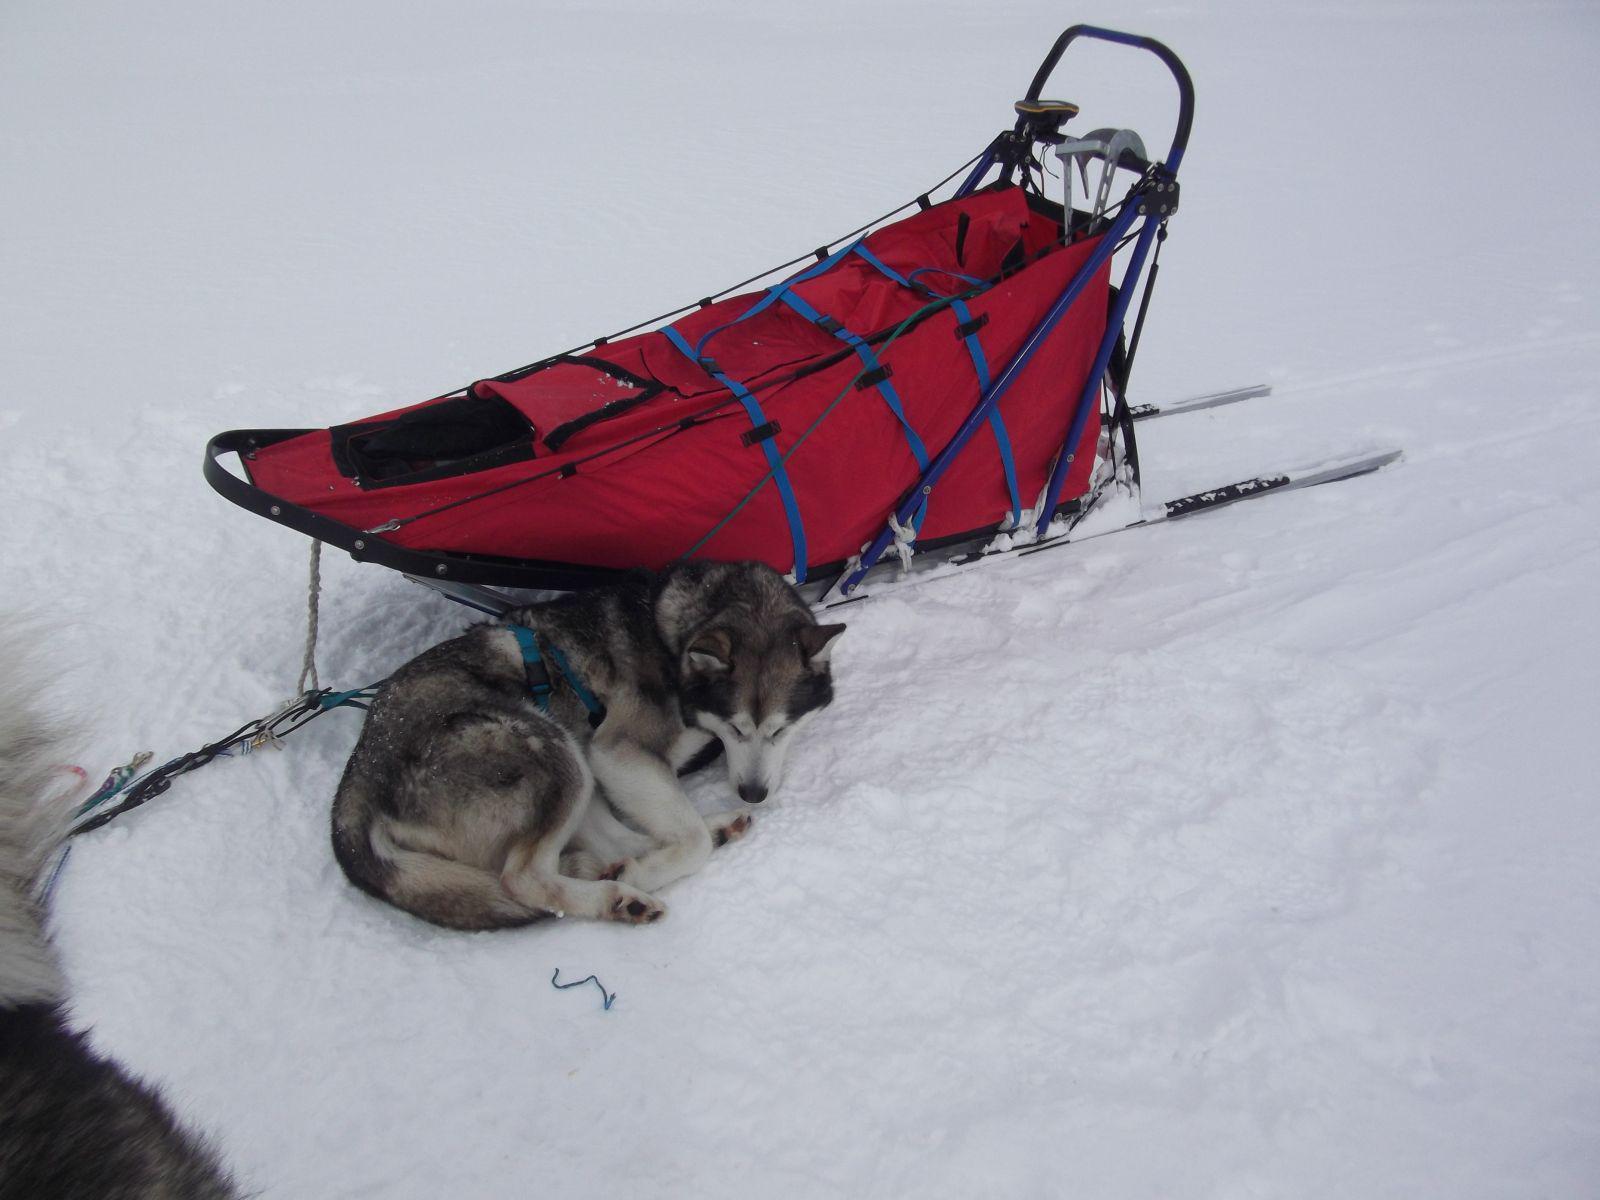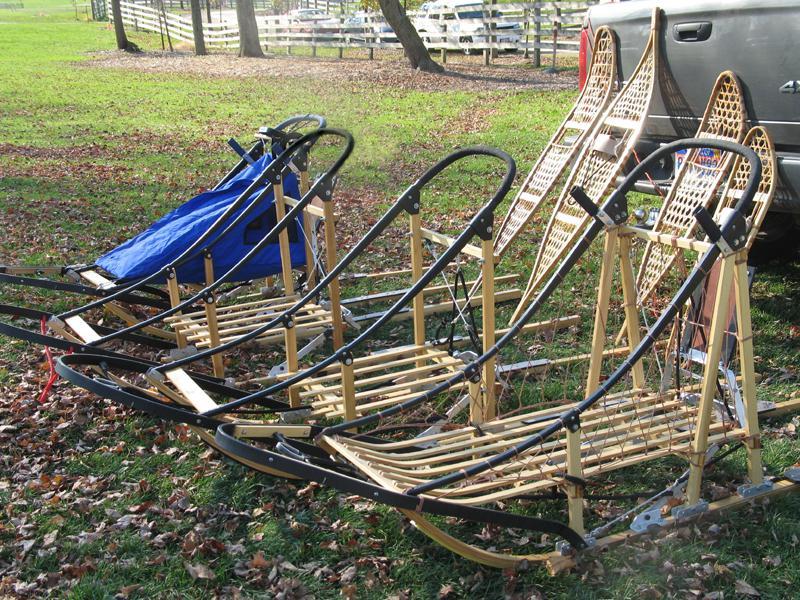The first image is the image on the left, the second image is the image on the right. Evaluate the accuracy of this statement regarding the images: "The left image shows a dog in front of a riderless sled featuring red on it, and the right image shows a row of empty sleds.". Is it true? Answer yes or no. Yes. 